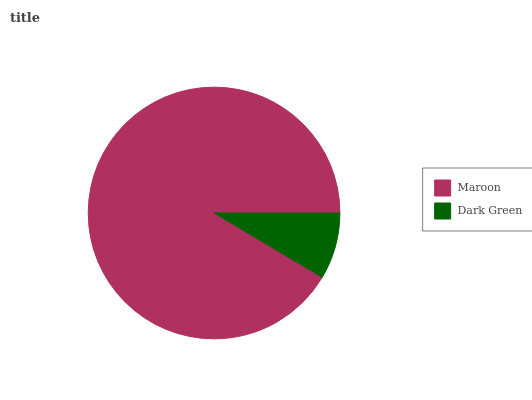Is Dark Green the minimum?
Answer yes or no. Yes. Is Maroon the maximum?
Answer yes or no. Yes. Is Dark Green the maximum?
Answer yes or no. No. Is Maroon greater than Dark Green?
Answer yes or no. Yes. Is Dark Green less than Maroon?
Answer yes or no. Yes. Is Dark Green greater than Maroon?
Answer yes or no. No. Is Maroon less than Dark Green?
Answer yes or no. No. Is Maroon the high median?
Answer yes or no. Yes. Is Dark Green the low median?
Answer yes or no. Yes. Is Dark Green the high median?
Answer yes or no. No. Is Maroon the low median?
Answer yes or no. No. 